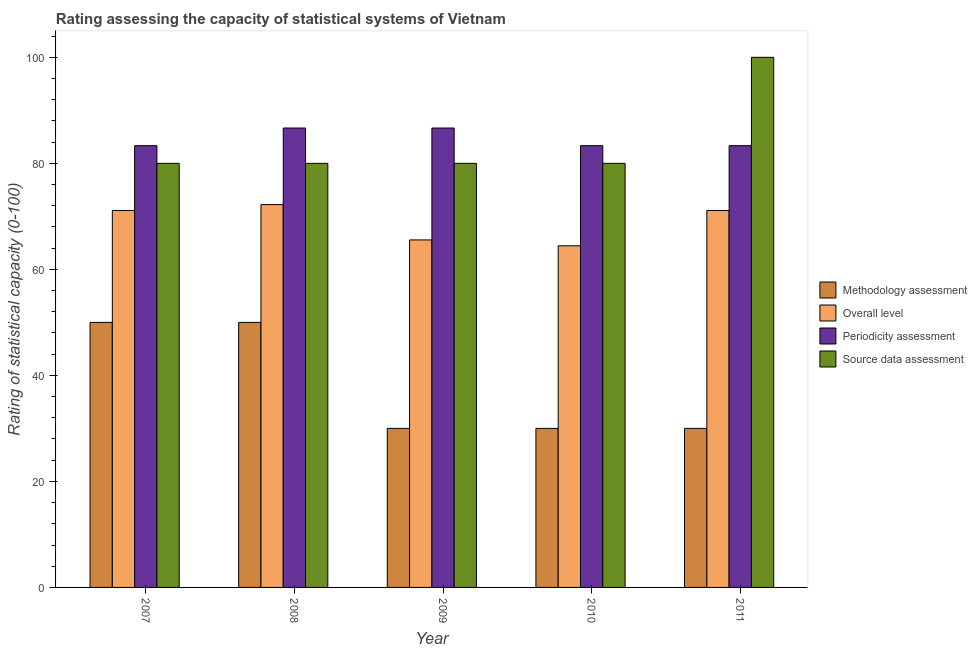How many different coloured bars are there?
Your answer should be compact. 4. How many groups of bars are there?
Your response must be concise. 5. Are the number of bars on each tick of the X-axis equal?
Offer a terse response. Yes. What is the label of the 4th group of bars from the left?
Offer a very short reply. 2010. What is the methodology assessment rating in 2009?
Ensure brevity in your answer.  30. Across all years, what is the maximum methodology assessment rating?
Provide a short and direct response. 50. Across all years, what is the minimum source data assessment rating?
Your answer should be very brief. 80. In which year was the methodology assessment rating minimum?
Your answer should be very brief. 2009. What is the total overall level rating in the graph?
Give a very brief answer. 344.44. What is the difference between the overall level rating in 2009 and that in 2010?
Your response must be concise. 1.11. What is the difference between the source data assessment rating in 2008 and the overall level rating in 2010?
Give a very brief answer. 0. What is the average overall level rating per year?
Give a very brief answer. 68.89. In how many years, is the methodology assessment rating greater than 32?
Your answer should be compact. 2. What is the ratio of the overall level rating in 2009 to that in 2011?
Your answer should be very brief. 0.92. Is the difference between the methodology assessment rating in 2009 and 2010 greater than the difference between the periodicity assessment rating in 2009 and 2010?
Your answer should be compact. No. What is the difference between the highest and the second highest overall level rating?
Your response must be concise. 1.11. What is the difference between the highest and the lowest methodology assessment rating?
Your response must be concise. 20. Is the sum of the overall level rating in 2008 and 2011 greater than the maximum source data assessment rating across all years?
Offer a terse response. Yes. What does the 4th bar from the left in 2008 represents?
Offer a terse response. Source data assessment. What does the 3rd bar from the right in 2009 represents?
Keep it short and to the point. Overall level. Is it the case that in every year, the sum of the methodology assessment rating and overall level rating is greater than the periodicity assessment rating?
Your answer should be very brief. Yes. How many bars are there?
Ensure brevity in your answer.  20. Are all the bars in the graph horizontal?
Your answer should be very brief. No. What is the difference between two consecutive major ticks on the Y-axis?
Provide a succinct answer. 20. Does the graph contain grids?
Keep it short and to the point. No. Where does the legend appear in the graph?
Make the answer very short. Center right. How many legend labels are there?
Your answer should be compact. 4. How are the legend labels stacked?
Provide a short and direct response. Vertical. What is the title of the graph?
Make the answer very short. Rating assessing the capacity of statistical systems of Vietnam. What is the label or title of the Y-axis?
Give a very brief answer. Rating of statistical capacity (0-100). What is the Rating of statistical capacity (0-100) of Overall level in 2007?
Ensure brevity in your answer.  71.11. What is the Rating of statistical capacity (0-100) of Periodicity assessment in 2007?
Make the answer very short. 83.33. What is the Rating of statistical capacity (0-100) of Overall level in 2008?
Your response must be concise. 72.22. What is the Rating of statistical capacity (0-100) of Periodicity assessment in 2008?
Your answer should be very brief. 86.67. What is the Rating of statistical capacity (0-100) of Methodology assessment in 2009?
Provide a succinct answer. 30. What is the Rating of statistical capacity (0-100) in Overall level in 2009?
Ensure brevity in your answer.  65.56. What is the Rating of statistical capacity (0-100) of Periodicity assessment in 2009?
Give a very brief answer. 86.67. What is the Rating of statistical capacity (0-100) in Source data assessment in 2009?
Offer a very short reply. 80. What is the Rating of statistical capacity (0-100) of Methodology assessment in 2010?
Keep it short and to the point. 30. What is the Rating of statistical capacity (0-100) in Overall level in 2010?
Keep it short and to the point. 64.44. What is the Rating of statistical capacity (0-100) in Periodicity assessment in 2010?
Give a very brief answer. 83.33. What is the Rating of statistical capacity (0-100) of Methodology assessment in 2011?
Ensure brevity in your answer.  30. What is the Rating of statistical capacity (0-100) in Overall level in 2011?
Ensure brevity in your answer.  71.11. What is the Rating of statistical capacity (0-100) of Periodicity assessment in 2011?
Ensure brevity in your answer.  83.33. Across all years, what is the maximum Rating of statistical capacity (0-100) of Overall level?
Offer a very short reply. 72.22. Across all years, what is the maximum Rating of statistical capacity (0-100) in Periodicity assessment?
Provide a succinct answer. 86.67. Across all years, what is the maximum Rating of statistical capacity (0-100) of Source data assessment?
Your answer should be very brief. 100. Across all years, what is the minimum Rating of statistical capacity (0-100) of Overall level?
Offer a very short reply. 64.44. Across all years, what is the minimum Rating of statistical capacity (0-100) in Periodicity assessment?
Give a very brief answer. 83.33. What is the total Rating of statistical capacity (0-100) in Methodology assessment in the graph?
Your answer should be very brief. 190. What is the total Rating of statistical capacity (0-100) in Overall level in the graph?
Make the answer very short. 344.44. What is the total Rating of statistical capacity (0-100) in Periodicity assessment in the graph?
Provide a short and direct response. 423.33. What is the total Rating of statistical capacity (0-100) of Source data assessment in the graph?
Provide a short and direct response. 420. What is the difference between the Rating of statistical capacity (0-100) of Overall level in 2007 and that in 2008?
Your answer should be compact. -1.11. What is the difference between the Rating of statistical capacity (0-100) in Source data assessment in 2007 and that in 2008?
Offer a terse response. 0. What is the difference between the Rating of statistical capacity (0-100) of Overall level in 2007 and that in 2009?
Offer a terse response. 5.56. What is the difference between the Rating of statistical capacity (0-100) of Periodicity assessment in 2007 and that in 2009?
Your response must be concise. -3.33. What is the difference between the Rating of statistical capacity (0-100) in Methodology assessment in 2007 and that in 2010?
Provide a short and direct response. 20. What is the difference between the Rating of statistical capacity (0-100) in Source data assessment in 2007 and that in 2010?
Provide a short and direct response. 0. What is the difference between the Rating of statistical capacity (0-100) of Periodicity assessment in 2007 and that in 2011?
Offer a terse response. 0. What is the difference between the Rating of statistical capacity (0-100) in Source data assessment in 2007 and that in 2011?
Keep it short and to the point. -20. What is the difference between the Rating of statistical capacity (0-100) of Overall level in 2008 and that in 2009?
Offer a very short reply. 6.67. What is the difference between the Rating of statistical capacity (0-100) in Periodicity assessment in 2008 and that in 2009?
Provide a short and direct response. 0. What is the difference between the Rating of statistical capacity (0-100) of Source data assessment in 2008 and that in 2009?
Keep it short and to the point. 0. What is the difference between the Rating of statistical capacity (0-100) of Methodology assessment in 2008 and that in 2010?
Provide a succinct answer. 20. What is the difference between the Rating of statistical capacity (0-100) of Overall level in 2008 and that in 2010?
Provide a succinct answer. 7.78. What is the difference between the Rating of statistical capacity (0-100) of Source data assessment in 2008 and that in 2010?
Ensure brevity in your answer.  0. What is the difference between the Rating of statistical capacity (0-100) of Methodology assessment in 2008 and that in 2011?
Your response must be concise. 20. What is the difference between the Rating of statistical capacity (0-100) of Periodicity assessment in 2008 and that in 2011?
Your response must be concise. 3.33. What is the difference between the Rating of statistical capacity (0-100) in Periodicity assessment in 2009 and that in 2010?
Your answer should be compact. 3.33. What is the difference between the Rating of statistical capacity (0-100) in Source data assessment in 2009 and that in 2010?
Provide a short and direct response. 0. What is the difference between the Rating of statistical capacity (0-100) of Overall level in 2009 and that in 2011?
Ensure brevity in your answer.  -5.56. What is the difference between the Rating of statistical capacity (0-100) in Periodicity assessment in 2009 and that in 2011?
Keep it short and to the point. 3.33. What is the difference between the Rating of statistical capacity (0-100) in Overall level in 2010 and that in 2011?
Provide a short and direct response. -6.67. What is the difference between the Rating of statistical capacity (0-100) of Source data assessment in 2010 and that in 2011?
Your response must be concise. -20. What is the difference between the Rating of statistical capacity (0-100) of Methodology assessment in 2007 and the Rating of statistical capacity (0-100) of Overall level in 2008?
Ensure brevity in your answer.  -22.22. What is the difference between the Rating of statistical capacity (0-100) of Methodology assessment in 2007 and the Rating of statistical capacity (0-100) of Periodicity assessment in 2008?
Make the answer very short. -36.67. What is the difference between the Rating of statistical capacity (0-100) in Overall level in 2007 and the Rating of statistical capacity (0-100) in Periodicity assessment in 2008?
Offer a very short reply. -15.56. What is the difference between the Rating of statistical capacity (0-100) in Overall level in 2007 and the Rating of statistical capacity (0-100) in Source data assessment in 2008?
Make the answer very short. -8.89. What is the difference between the Rating of statistical capacity (0-100) in Periodicity assessment in 2007 and the Rating of statistical capacity (0-100) in Source data assessment in 2008?
Ensure brevity in your answer.  3.33. What is the difference between the Rating of statistical capacity (0-100) of Methodology assessment in 2007 and the Rating of statistical capacity (0-100) of Overall level in 2009?
Your answer should be compact. -15.56. What is the difference between the Rating of statistical capacity (0-100) in Methodology assessment in 2007 and the Rating of statistical capacity (0-100) in Periodicity assessment in 2009?
Your answer should be very brief. -36.67. What is the difference between the Rating of statistical capacity (0-100) of Methodology assessment in 2007 and the Rating of statistical capacity (0-100) of Source data assessment in 2009?
Make the answer very short. -30. What is the difference between the Rating of statistical capacity (0-100) of Overall level in 2007 and the Rating of statistical capacity (0-100) of Periodicity assessment in 2009?
Ensure brevity in your answer.  -15.56. What is the difference between the Rating of statistical capacity (0-100) of Overall level in 2007 and the Rating of statistical capacity (0-100) of Source data assessment in 2009?
Offer a very short reply. -8.89. What is the difference between the Rating of statistical capacity (0-100) of Periodicity assessment in 2007 and the Rating of statistical capacity (0-100) of Source data assessment in 2009?
Provide a succinct answer. 3.33. What is the difference between the Rating of statistical capacity (0-100) in Methodology assessment in 2007 and the Rating of statistical capacity (0-100) in Overall level in 2010?
Ensure brevity in your answer.  -14.44. What is the difference between the Rating of statistical capacity (0-100) in Methodology assessment in 2007 and the Rating of statistical capacity (0-100) in Periodicity assessment in 2010?
Provide a succinct answer. -33.33. What is the difference between the Rating of statistical capacity (0-100) of Overall level in 2007 and the Rating of statistical capacity (0-100) of Periodicity assessment in 2010?
Your answer should be very brief. -12.22. What is the difference between the Rating of statistical capacity (0-100) of Overall level in 2007 and the Rating of statistical capacity (0-100) of Source data assessment in 2010?
Your answer should be very brief. -8.89. What is the difference between the Rating of statistical capacity (0-100) in Methodology assessment in 2007 and the Rating of statistical capacity (0-100) in Overall level in 2011?
Provide a short and direct response. -21.11. What is the difference between the Rating of statistical capacity (0-100) in Methodology assessment in 2007 and the Rating of statistical capacity (0-100) in Periodicity assessment in 2011?
Your answer should be very brief. -33.33. What is the difference between the Rating of statistical capacity (0-100) of Methodology assessment in 2007 and the Rating of statistical capacity (0-100) of Source data assessment in 2011?
Offer a terse response. -50. What is the difference between the Rating of statistical capacity (0-100) in Overall level in 2007 and the Rating of statistical capacity (0-100) in Periodicity assessment in 2011?
Give a very brief answer. -12.22. What is the difference between the Rating of statistical capacity (0-100) in Overall level in 2007 and the Rating of statistical capacity (0-100) in Source data assessment in 2011?
Provide a short and direct response. -28.89. What is the difference between the Rating of statistical capacity (0-100) in Periodicity assessment in 2007 and the Rating of statistical capacity (0-100) in Source data assessment in 2011?
Make the answer very short. -16.67. What is the difference between the Rating of statistical capacity (0-100) of Methodology assessment in 2008 and the Rating of statistical capacity (0-100) of Overall level in 2009?
Keep it short and to the point. -15.56. What is the difference between the Rating of statistical capacity (0-100) of Methodology assessment in 2008 and the Rating of statistical capacity (0-100) of Periodicity assessment in 2009?
Offer a very short reply. -36.67. What is the difference between the Rating of statistical capacity (0-100) of Overall level in 2008 and the Rating of statistical capacity (0-100) of Periodicity assessment in 2009?
Give a very brief answer. -14.44. What is the difference between the Rating of statistical capacity (0-100) of Overall level in 2008 and the Rating of statistical capacity (0-100) of Source data assessment in 2009?
Your response must be concise. -7.78. What is the difference between the Rating of statistical capacity (0-100) in Periodicity assessment in 2008 and the Rating of statistical capacity (0-100) in Source data assessment in 2009?
Offer a terse response. 6.67. What is the difference between the Rating of statistical capacity (0-100) in Methodology assessment in 2008 and the Rating of statistical capacity (0-100) in Overall level in 2010?
Make the answer very short. -14.44. What is the difference between the Rating of statistical capacity (0-100) in Methodology assessment in 2008 and the Rating of statistical capacity (0-100) in Periodicity assessment in 2010?
Keep it short and to the point. -33.33. What is the difference between the Rating of statistical capacity (0-100) in Methodology assessment in 2008 and the Rating of statistical capacity (0-100) in Source data assessment in 2010?
Ensure brevity in your answer.  -30. What is the difference between the Rating of statistical capacity (0-100) in Overall level in 2008 and the Rating of statistical capacity (0-100) in Periodicity assessment in 2010?
Offer a very short reply. -11.11. What is the difference between the Rating of statistical capacity (0-100) in Overall level in 2008 and the Rating of statistical capacity (0-100) in Source data assessment in 2010?
Offer a very short reply. -7.78. What is the difference between the Rating of statistical capacity (0-100) of Methodology assessment in 2008 and the Rating of statistical capacity (0-100) of Overall level in 2011?
Keep it short and to the point. -21.11. What is the difference between the Rating of statistical capacity (0-100) of Methodology assessment in 2008 and the Rating of statistical capacity (0-100) of Periodicity assessment in 2011?
Provide a short and direct response. -33.33. What is the difference between the Rating of statistical capacity (0-100) of Overall level in 2008 and the Rating of statistical capacity (0-100) of Periodicity assessment in 2011?
Ensure brevity in your answer.  -11.11. What is the difference between the Rating of statistical capacity (0-100) in Overall level in 2008 and the Rating of statistical capacity (0-100) in Source data assessment in 2011?
Ensure brevity in your answer.  -27.78. What is the difference between the Rating of statistical capacity (0-100) of Periodicity assessment in 2008 and the Rating of statistical capacity (0-100) of Source data assessment in 2011?
Give a very brief answer. -13.33. What is the difference between the Rating of statistical capacity (0-100) in Methodology assessment in 2009 and the Rating of statistical capacity (0-100) in Overall level in 2010?
Keep it short and to the point. -34.44. What is the difference between the Rating of statistical capacity (0-100) in Methodology assessment in 2009 and the Rating of statistical capacity (0-100) in Periodicity assessment in 2010?
Your response must be concise. -53.33. What is the difference between the Rating of statistical capacity (0-100) of Overall level in 2009 and the Rating of statistical capacity (0-100) of Periodicity assessment in 2010?
Ensure brevity in your answer.  -17.78. What is the difference between the Rating of statistical capacity (0-100) of Overall level in 2009 and the Rating of statistical capacity (0-100) of Source data assessment in 2010?
Provide a short and direct response. -14.44. What is the difference between the Rating of statistical capacity (0-100) of Periodicity assessment in 2009 and the Rating of statistical capacity (0-100) of Source data assessment in 2010?
Offer a very short reply. 6.67. What is the difference between the Rating of statistical capacity (0-100) in Methodology assessment in 2009 and the Rating of statistical capacity (0-100) in Overall level in 2011?
Keep it short and to the point. -41.11. What is the difference between the Rating of statistical capacity (0-100) of Methodology assessment in 2009 and the Rating of statistical capacity (0-100) of Periodicity assessment in 2011?
Offer a terse response. -53.33. What is the difference between the Rating of statistical capacity (0-100) of Methodology assessment in 2009 and the Rating of statistical capacity (0-100) of Source data assessment in 2011?
Offer a very short reply. -70. What is the difference between the Rating of statistical capacity (0-100) of Overall level in 2009 and the Rating of statistical capacity (0-100) of Periodicity assessment in 2011?
Your answer should be compact. -17.78. What is the difference between the Rating of statistical capacity (0-100) of Overall level in 2009 and the Rating of statistical capacity (0-100) of Source data assessment in 2011?
Offer a terse response. -34.44. What is the difference between the Rating of statistical capacity (0-100) of Periodicity assessment in 2009 and the Rating of statistical capacity (0-100) of Source data assessment in 2011?
Keep it short and to the point. -13.33. What is the difference between the Rating of statistical capacity (0-100) in Methodology assessment in 2010 and the Rating of statistical capacity (0-100) in Overall level in 2011?
Your answer should be compact. -41.11. What is the difference between the Rating of statistical capacity (0-100) in Methodology assessment in 2010 and the Rating of statistical capacity (0-100) in Periodicity assessment in 2011?
Offer a very short reply. -53.33. What is the difference between the Rating of statistical capacity (0-100) of Methodology assessment in 2010 and the Rating of statistical capacity (0-100) of Source data assessment in 2011?
Keep it short and to the point. -70. What is the difference between the Rating of statistical capacity (0-100) of Overall level in 2010 and the Rating of statistical capacity (0-100) of Periodicity assessment in 2011?
Provide a succinct answer. -18.89. What is the difference between the Rating of statistical capacity (0-100) in Overall level in 2010 and the Rating of statistical capacity (0-100) in Source data assessment in 2011?
Keep it short and to the point. -35.56. What is the difference between the Rating of statistical capacity (0-100) of Periodicity assessment in 2010 and the Rating of statistical capacity (0-100) of Source data assessment in 2011?
Provide a short and direct response. -16.67. What is the average Rating of statistical capacity (0-100) in Methodology assessment per year?
Ensure brevity in your answer.  38. What is the average Rating of statistical capacity (0-100) of Overall level per year?
Offer a terse response. 68.89. What is the average Rating of statistical capacity (0-100) of Periodicity assessment per year?
Provide a short and direct response. 84.67. In the year 2007, what is the difference between the Rating of statistical capacity (0-100) of Methodology assessment and Rating of statistical capacity (0-100) of Overall level?
Provide a succinct answer. -21.11. In the year 2007, what is the difference between the Rating of statistical capacity (0-100) of Methodology assessment and Rating of statistical capacity (0-100) of Periodicity assessment?
Give a very brief answer. -33.33. In the year 2007, what is the difference between the Rating of statistical capacity (0-100) in Overall level and Rating of statistical capacity (0-100) in Periodicity assessment?
Offer a very short reply. -12.22. In the year 2007, what is the difference between the Rating of statistical capacity (0-100) of Overall level and Rating of statistical capacity (0-100) of Source data assessment?
Offer a very short reply. -8.89. In the year 2008, what is the difference between the Rating of statistical capacity (0-100) of Methodology assessment and Rating of statistical capacity (0-100) of Overall level?
Provide a short and direct response. -22.22. In the year 2008, what is the difference between the Rating of statistical capacity (0-100) in Methodology assessment and Rating of statistical capacity (0-100) in Periodicity assessment?
Keep it short and to the point. -36.67. In the year 2008, what is the difference between the Rating of statistical capacity (0-100) of Overall level and Rating of statistical capacity (0-100) of Periodicity assessment?
Keep it short and to the point. -14.44. In the year 2008, what is the difference between the Rating of statistical capacity (0-100) of Overall level and Rating of statistical capacity (0-100) of Source data assessment?
Your response must be concise. -7.78. In the year 2009, what is the difference between the Rating of statistical capacity (0-100) in Methodology assessment and Rating of statistical capacity (0-100) in Overall level?
Give a very brief answer. -35.56. In the year 2009, what is the difference between the Rating of statistical capacity (0-100) in Methodology assessment and Rating of statistical capacity (0-100) in Periodicity assessment?
Your response must be concise. -56.67. In the year 2009, what is the difference between the Rating of statistical capacity (0-100) in Methodology assessment and Rating of statistical capacity (0-100) in Source data assessment?
Your answer should be very brief. -50. In the year 2009, what is the difference between the Rating of statistical capacity (0-100) of Overall level and Rating of statistical capacity (0-100) of Periodicity assessment?
Offer a terse response. -21.11. In the year 2009, what is the difference between the Rating of statistical capacity (0-100) of Overall level and Rating of statistical capacity (0-100) of Source data assessment?
Provide a short and direct response. -14.44. In the year 2010, what is the difference between the Rating of statistical capacity (0-100) in Methodology assessment and Rating of statistical capacity (0-100) in Overall level?
Your answer should be compact. -34.44. In the year 2010, what is the difference between the Rating of statistical capacity (0-100) in Methodology assessment and Rating of statistical capacity (0-100) in Periodicity assessment?
Your answer should be compact. -53.33. In the year 2010, what is the difference between the Rating of statistical capacity (0-100) of Overall level and Rating of statistical capacity (0-100) of Periodicity assessment?
Provide a short and direct response. -18.89. In the year 2010, what is the difference between the Rating of statistical capacity (0-100) in Overall level and Rating of statistical capacity (0-100) in Source data assessment?
Your answer should be compact. -15.56. In the year 2010, what is the difference between the Rating of statistical capacity (0-100) of Periodicity assessment and Rating of statistical capacity (0-100) of Source data assessment?
Offer a very short reply. 3.33. In the year 2011, what is the difference between the Rating of statistical capacity (0-100) of Methodology assessment and Rating of statistical capacity (0-100) of Overall level?
Keep it short and to the point. -41.11. In the year 2011, what is the difference between the Rating of statistical capacity (0-100) of Methodology assessment and Rating of statistical capacity (0-100) of Periodicity assessment?
Offer a terse response. -53.33. In the year 2011, what is the difference between the Rating of statistical capacity (0-100) of Methodology assessment and Rating of statistical capacity (0-100) of Source data assessment?
Provide a succinct answer. -70. In the year 2011, what is the difference between the Rating of statistical capacity (0-100) of Overall level and Rating of statistical capacity (0-100) of Periodicity assessment?
Give a very brief answer. -12.22. In the year 2011, what is the difference between the Rating of statistical capacity (0-100) in Overall level and Rating of statistical capacity (0-100) in Source data assessment?
Provide a succinct answer. -28.89. In the year 2011, what is the difference between the Rating of statistical capacity (0-100) of Periodicity assessment and Rating of statistical capacity (0-100) of Source data assessment?
Make the answer very short. -16.67. What is the ratio of the Rating of statistical capacity (0-100) in Methodology assessment in 2007 to that in 2008?
Keep it short and to the point. 1. What is the ratio of the Rating of statistical capacity (0-100) of Overall level in 2007 to that in 2008?
Your response must be concise. 0.98. What is the ratio of the Rating of statistical capacity (0-100) in Periodicity assessment in 2007 to that in 2008?
Ensure brevity in your answer.  0.96. What is the ratio of the Rating of statistical capacity (0-100) of Overall level in 2007 to that in 2009?
Provide a succinct answer. 1.08. What is the ratio of the Rating of statistical capacity (0-100) in Periodicity assessment in 2007 to that in 2009?
Provide a succinct answer. 0.96. What is the ratio of the Rating of statistical capacity (0-100) in Methodology assessment in 2007 to that in 2010?
Your answer should be very brief. 1.67. What is the ratio of the Rating of statistical capacity (0-100) of Overall level in 2007 to that in 2010?
Provide a succinct answer. 1.1. What is the ratio of the Rating of statistical capacity (0-100) in Methodology assessment in 2007 to that in 2011?
Provide a short and direct response. 1.67. What is the ratio of the Rating of statistical capacity (0-100) in Periodicity assessment in 2007 to that in 2011?
Your answer should be compact. 1. What is the ratio of the Rating of statistical capacity (0-100) in Source data assessment in 2007 to that in 2011?
Provide a succinct answer. 0.8. What is the ratio of the Rating of statistical capacity (0-100) in Overall level in 2008 to that in 2009?
Your answer should be very brief. 1.1. What is the ratio of the Rating of statistical capacity (0-100) of Source data assessment in 2008 to that in 2009?
Provide a short and direct response. 1. What is the ratio of the Rating of statistical capacity (0-100) in Overall level in 2008 to that in 2010?
Ensure brevity in your answer.  1.12. What is the ratio of the Rating of statistical capacity (0-100) of Overall level in 2008 to that in 2011?
Ensure brevity in your answer.  1.02. What is the ratio of the Rating of statistical capacity (0-100) of Methodology assessment in 2009 to that in 2010?
Keep it short and to the point. 1. What is the ratio of the Rating of statistical capacity (0-100) in Overall level in 2009 to that in 2010?
Offer a terse response. 1.02. What is the ratio of the Rating of statistical capacity (0-100) in Periodicity assessment in 2009 to that in 2010?
Provide a succinct answer. 1.04. What is the ratio of the Rating of statistical capacity (0-100) in Source data assessment in 2009 to that in 2010?
Ensure brevity in your answer.  1. What is the ratio of the Rating of statistical capacity (0-100) of Methodology assessment in 2009 to that in 2011?
Your answer should be very brief. 1. What is the ratio of the Rating of statistical capacity (0-100) in Overall level in 2009 to that in 2011?
Keep it short and to the point. 0.92. What is the ratio of the Rating of statistical capacity (0-100) of Source data assessment in 2009 to that in 2011?
Your answer should be very brief. 0.8. What is the ratio of the Rating of statistical capacity (0-100) in Methodology assessment in 2010 to that in 2011?
Give a very brief answer. 1. What is the ratio of the Rating of statistical capacity (0-100) of Overall level in 2010 to that in 2011?
Offer a very short reply. 0.91. What is the difference between the highest and the second highest Rating of statistical capacity (0-100) in Methodology assessment?
Offer a very short reply. 0. What is the difference between the highest and the second highest Rating of statistical capacity (0-100) in Overall level?
Ensure brevity in your answer.  1.11. What is the difference between the highest and the second highest Rating of statistical capacity (0-100) of Periodicity assessment?
Provide a short and direct response. 0. What is the difference between the highest and the second highest Rating of statistical capacity (0-100) of Source data assessment?
Keep it short and to the point. 20. What is the difference between the highest and the lowest Rating of statistical capacity (0-100) in Methodology assessment?
Offer a very short reply. 20. What is the difference between the highest and the lowest Rating of statistical capacity (0-100) of Overall level?
Provide a short and direct response. 7.78. What is the difference between the highest and the lowest Rating of statistical capacity (0-100) of Source data assessment?
Offer a very short reply. 20. 